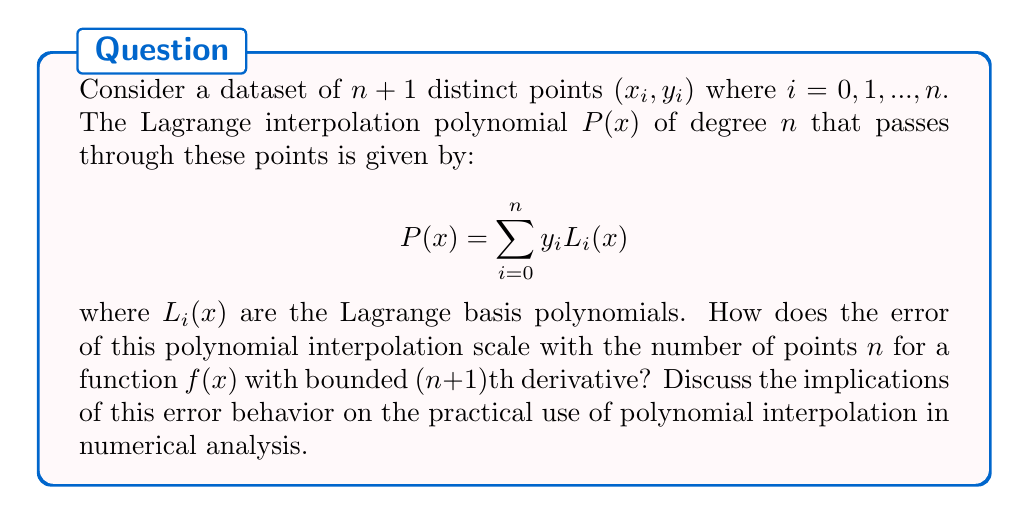Can you answer this question? To understand the error behavior of polynomial interpolation, we need to consider the following steps:

1) The error of polynomial interpolation is given by the error formula:

   $$E(x) = f(x) - P(x) = \frac{f^{(n+1)}(\xi)}{(n+1)!} \prod_{i=0}^n (x - x_i)$$

   where $\xi$ is some point in the interval containing all $x_i$ and $x$.

2) If we assume that $|f^{(n+1)}(x)| \leq M$ for all $x$ in the interval, then:

   $$|E(x)| \leq \frac{M}{(n+1)!} |\prod_{i=0}^n (x - x_i)|$$

3) The term $|\prod_{i=0}^n (x - x_i)|$ is bounded by $(b-a)^{n+1}/4^n$, where $[a,b]$ is the interval containing all points. This leads to:

   $$|E(x)| \leq \frac{M(b-a)^{n+1}}{4^n(n+1)!}$$

4) As $n$ increases, $(n+1)!$ in the denominator grows faster than $(b-a)^{n+1}$ in the numerator, causing the error bound to decrease rapidly.

5) However, this theoretical error bound has limitations in practice:
   - It assumes a bounded $(n+1)$th derivative, which may not always hold.
   - For large $n$, the interpolating polynomial can become highly oscillatory (Runge's phenomenon).
   - Numerical instability can occur in computing the interpolation polynomial for large $n$.

These considerations highlight the trade-off between accuracy and stability in polynomial interpolation, which is crucial in numerical analysis applications.
Answer: The error of polynomial interpolation scales as $O(\frac{(b-a)^{n+1}}{4^n(n+1)!})$ for a function with bounded $(n+1)$th derivative. While this suggests rapid convergence as $n$ increases, practical limitations such as Runge's phenomenon and numerical instability often restrict the use of high-degree polynomial interpolation in numerical analysis. 